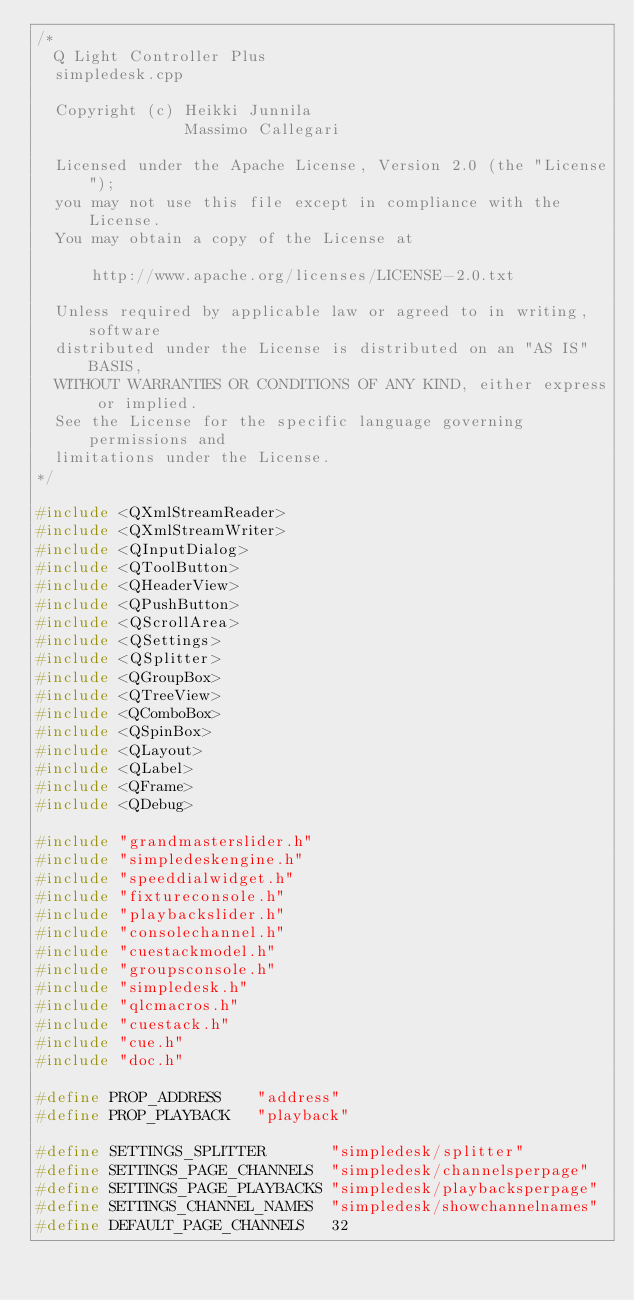Convert code to text. <code><loc_0><loc_0><loc_500><loc_500><_C++_>/*
  Q Light Controller Plus
  simpledesk.cpp

  Copyright (c) Heikki Junnila
                Massimo Callegari

  Licensed under the Apache License, Version 2.0 (the "License");
  you may not use this file except in compliance with the License.
  You may obtain a copy of the License at

      http://www.apache.org/licenses/LICENSE-2.0.txt

  Unless required by applicable law or agreed to in writing, software
  distributed under the License is distributed on an "AS IS" BASIS,
  WITHOUT WARRANTIES OR CONDITIONS OF ANY KIND, either express or implied.
  See the License for the specific language governing permissions and
  limitations under the License.
*/

#include <QXmlStreamReader>
#include <QXmlStreamWriter>
#include <QInputDialog>
#include <QToolButton>
#include <QHeaderView>
#include <QPushButton>
#include <QScrollArea>
#include <QSettings>
#include <QSplitter>
#include <QGroupBox>
#include <QTreeView>
#include <QComboBox>
#include <QSpinBox>
#include <QLayout>
#include <QLabel>
#include <QFrame>
#include <QDebug>

#include "grandmasterslider.h"
#include "simpledeskengine.h"
#include "speeddialwidget.h"
#include "fixtureconsole.h"
#include "playbackslider.h"
#include "consolechannel.h"
#include "cuestackmodel.h"
#include "groupsconsole.h"
#include "simpledesk.h"
#include "qlcmacros.h"
#include "cuestack.h"
#include "cue.h"
#include "doc.h"

#define PROP_ADDRESS    "address"
#define PROP_PLAYBACK   "playback"

#define SETTINGS_SPLITTER       "simpledesk/splitter"
#define SETTINGS_PAGE_CHANNELS  "simpledesk/channelsperpage"
#define SETTINGS_PAGE_PLAYBACKS "simpledesk/playbacksperpage"
#define SETTINGS_CHANNEL_NAMES  "simpledesk/showchannelnames"
#define DEFAULT_PAGE_CHANNELS   32</code> 